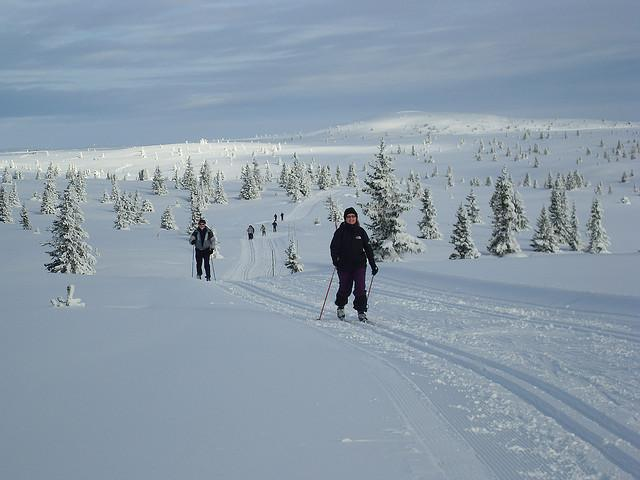What must the weather be like in this area? cold 